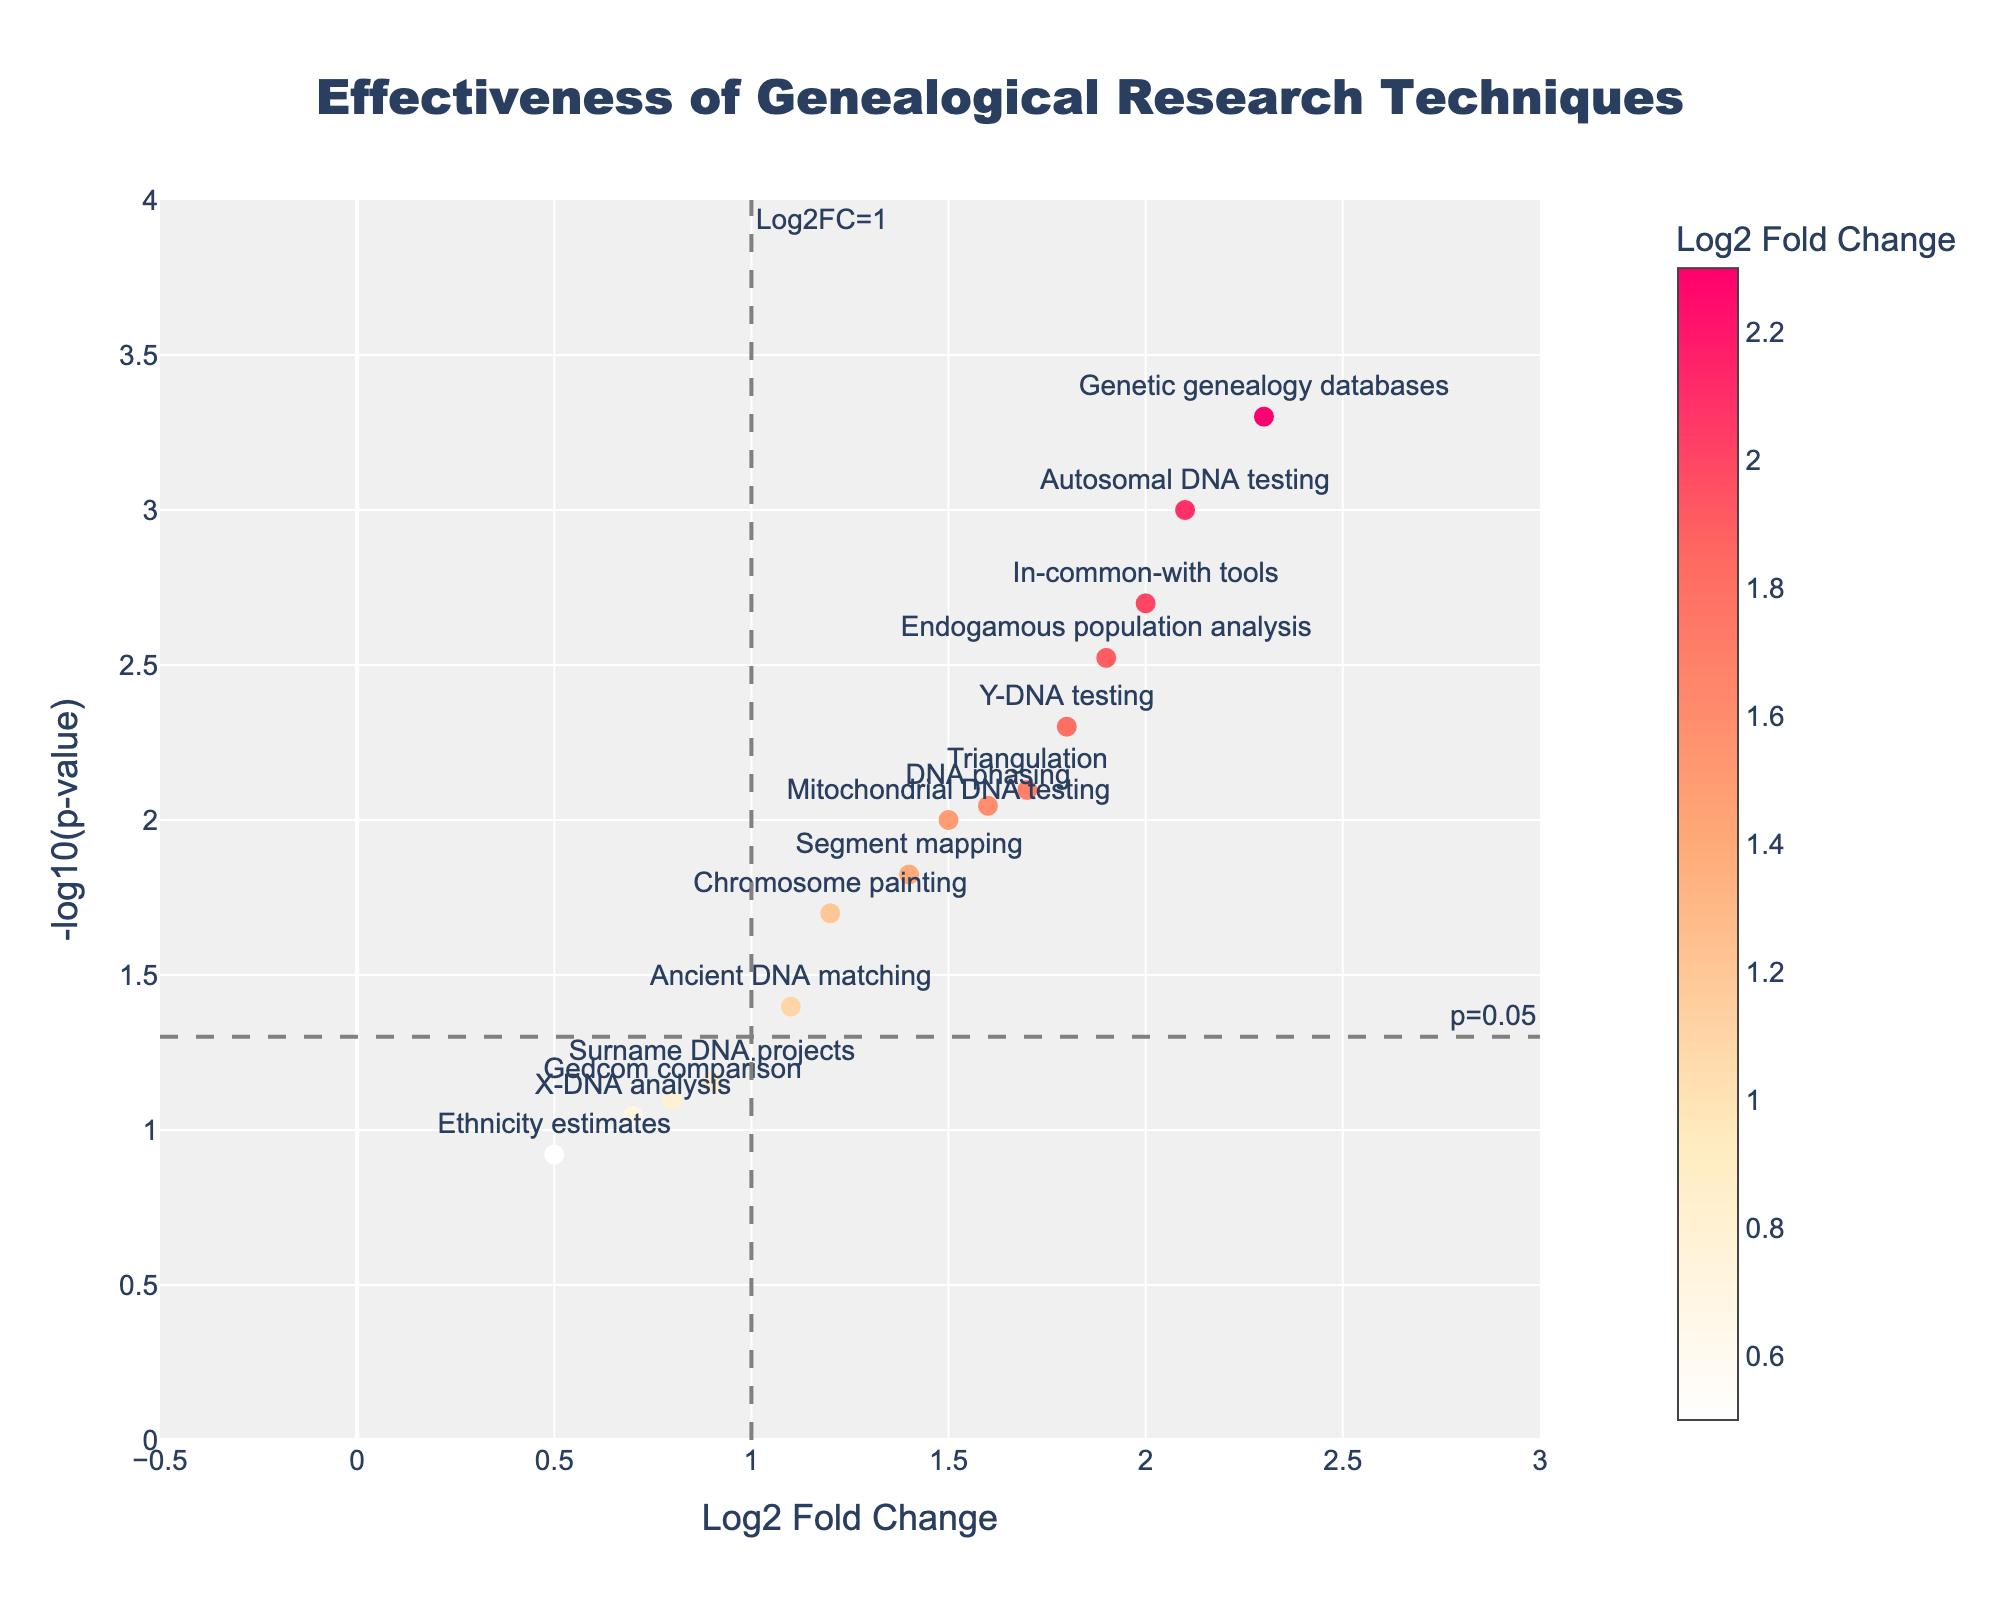What is the title of the figure? The title of the figure is displayed at the top. It says "Effectiveness of Genealogical Research Techniques."
Answer: Effectiveness of Genealogical Research Techniques What do the x- and y-axes represent in the plot? The x-axis represents the Log2 Fold Change, and the y-axis represents the -log10(p-value). These labels are visible along the respective axes.
Answer: Log2 Fold Change, -log10(p-value) How many data points are plotted in the figure? Count the number of marker points or labeled techniques in the plot. There are 15 data points visible.
Answer: 15 Which technique has the highest Log2 Fold Change? Look for the data point farthest to the right on the x-axis. The "Genetic genealogy databases" has the highest Log2 Fold Change.
Answer: Genetic genealogy databases Which technique has the lowest p-value? Locate the point with the highest value on the y-axis (since -log10(p-value) is plotted). The "Genetic genealogy databases" has the highest -log10(p-value), indicating the lowest p-value.
Answer: Genetic genealogy databases How many techniques have a Log2 Fold Change greater than 1? Count the number of data points to the right of the Log2FC=1 vertical line. There are 10 such techniques.
Answer: 10 Name the techniques that have a p-value less than 0.05. Identify the data points above the horizontal line at -log10(p-value) corresponding to 0.05. These are "Autosomal DNA testing," "Y-DNA testing," "Mitochondrial DNA testing," "Chromosome painting," "Genetic genealogy databases," "Triangulation," "Segment mapping," "Endogamous population analysis," "DNA phasing," and "In-common-with tools."
Answer: Autosomal DNA testing, Y-DNA testing, Mitochondrial DNA testing, Chromosome painting, Genetic genealogy databases, Triangulation, Segment mapping, Endogamous population analysis, DNA phasing, In-common-with tools Which technique has the lowest -log10(p-value) and what is its Log2 Fold Change? Locate the point with the smallest value on the y-axis. "Ethnicity estimates" have the lowest -log10(p-value), and its Log2 Fold Change is 0.5.
Answer: Ethnicity estimates, 0.5 Compare the -log10(p-value) for "Autosomal DNA testing" and "Triangulation." Which one is higher? Check the y-axis positions for these two techniques. "Autosomal DNA testing" has a higher -log10(p-value) than "Triangulation."
Answer: Autosomal DNA testing Which technique is closest to the Log2 Fold Change of 0.7 and what is its p-value? Find the data point or marker closest to 0.7 on the x-axis. "X-DNA analysis" corresponds to this value, and its p-value is 0.09.
Answer: X-DNA analysis, 0.09 Which data point is the closest to the (Log2 Fold Change, -log10(p-value)) coordinates of (1.8, 3)? Compare each technique's coordinates manually or visually approximate the locations. "Y-DNA testing" is the nearest point to these coordinates.
Answer: Y-DNA testing 